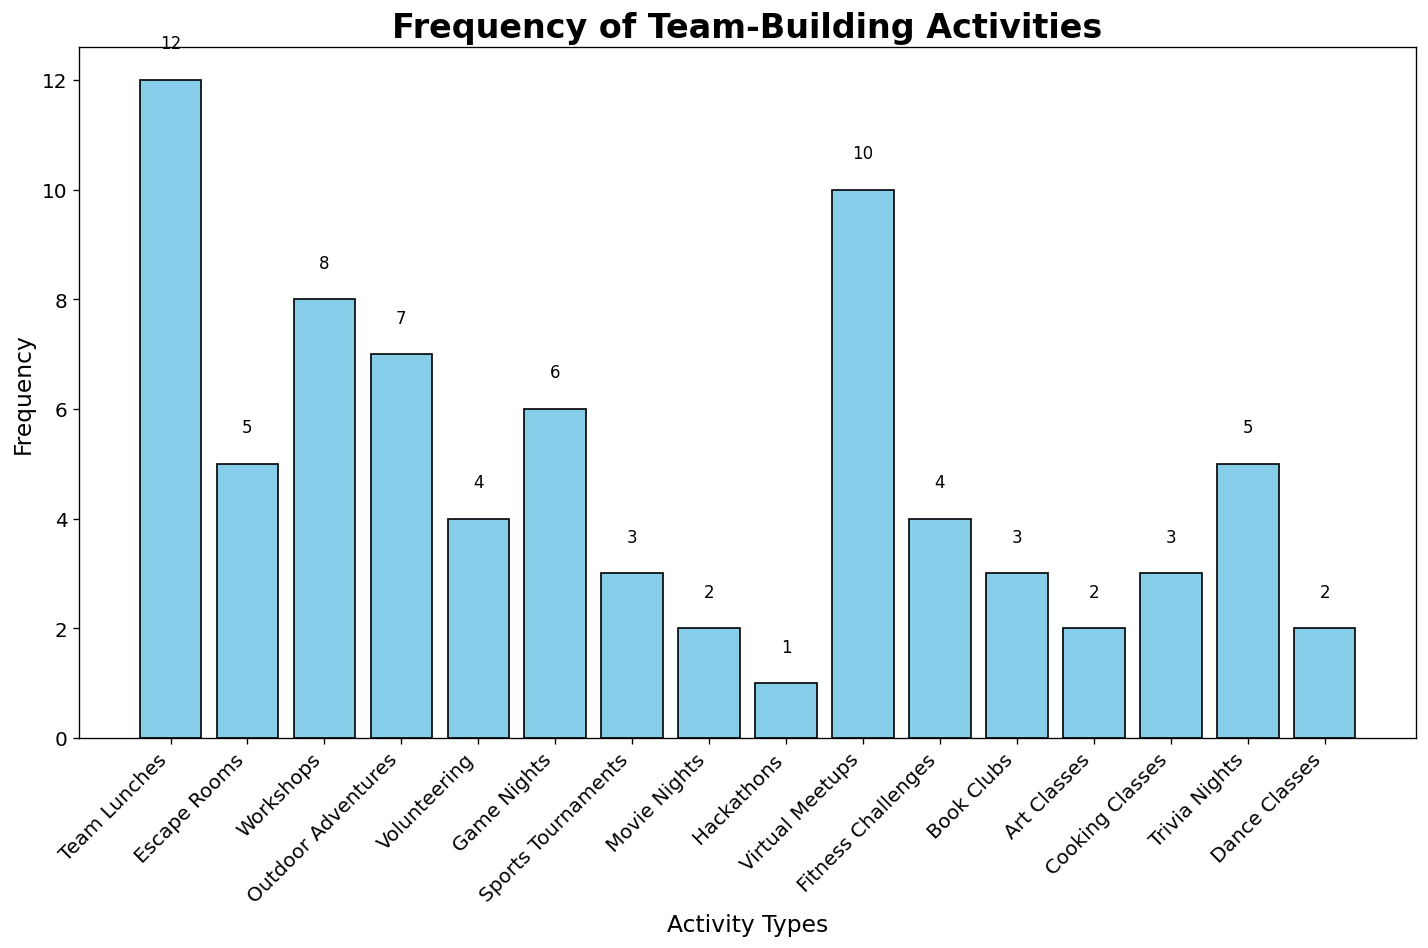What is the most frequently participated team-building activity? To determine the most frequently participated activity, identify the bar with the greatest height. The bar for Team Lunches is the tallest with a frequency of 12.
Answer: Team Lunches Which activity has a lower frequency, Game Nights or Escape Rooms? Compare the heights of the bars for Game Nights and Escape Rooms. Game Nights has a frequency of 6, while Escape Rooms has a frequency of 5. Since 5 is less than 6, Escape Rooms has a lower frequency.
Answer: Escape Rooms How many more times did people participate in Outdoor Adventures compared to Volunteering? Find the height of the bars for Outdoor Adventures and Volunteering. Outdoor Adventures has a frequency of 7, and Volunteering has a frequency of 4. Subtract 4 from 7 to find the difference. (7 - 4 = 3)
Answer: 3 What is the total frequency of activities participated less than 5 times? Identify the bars with frequencies less than 5: Volunteering (4), Sports Tournaments (3), Movie Nights (2), Hackathons (1), Art Classes (2), Cooking Classes (3), Dance Classes (2). Sum these frequencies: 4 + 3 + 2 + 1 + 2 + 3 + 2 = 17
Answer: 17 Identify the activities that were participated in exactly 3 times. Look for bars with a height of 3. The activities are Sports Tournaments, Book Clubs, and Cooking Classes.
Answer: Sports Tournaments, Book Clubs, Cooking Classes Among Virtual Meetups and Workshops, which activity has a higher participation frequency? Compare the heights of the bars for Virtual Meetups (10) and Workshops (8). Since 10 is greater than 8, Virtual Meetups has a higher frequency.
Answer: Virtual Meetups What is the average frequency of the top three most participated activities? Identify the top three most participated activities: Team Lunches (12), Virtual Meetups (10), and Workshops (8). Calculate their average: (12 + 10 + 8) / 3 = 10
Answer: 10 How many activities have a frequency between 5 and 10 (inclusive)? Count the bars with heights between 5 and 10: Escape Rooms (5), Workshops (8), Outdoor Adventures (7), Game Nights (6), Virtual Meetups (10), Trivia Nights (5). There are 6 such activities.
Answer: 6 Which activities have the same frequency of 2? Look for bars with a height of 2. The activities are Movie Nights, Art Classes, and Dance Classes.
Answer: Movie Nights, Art Classes, Dance Classes What is the combined frequency of all virtual team-building activities? Identify virtual activities and sum their frequencies: Virtual Meetups (10), Hackathons (1). (10 + 1 = 11)
Answer: 11 